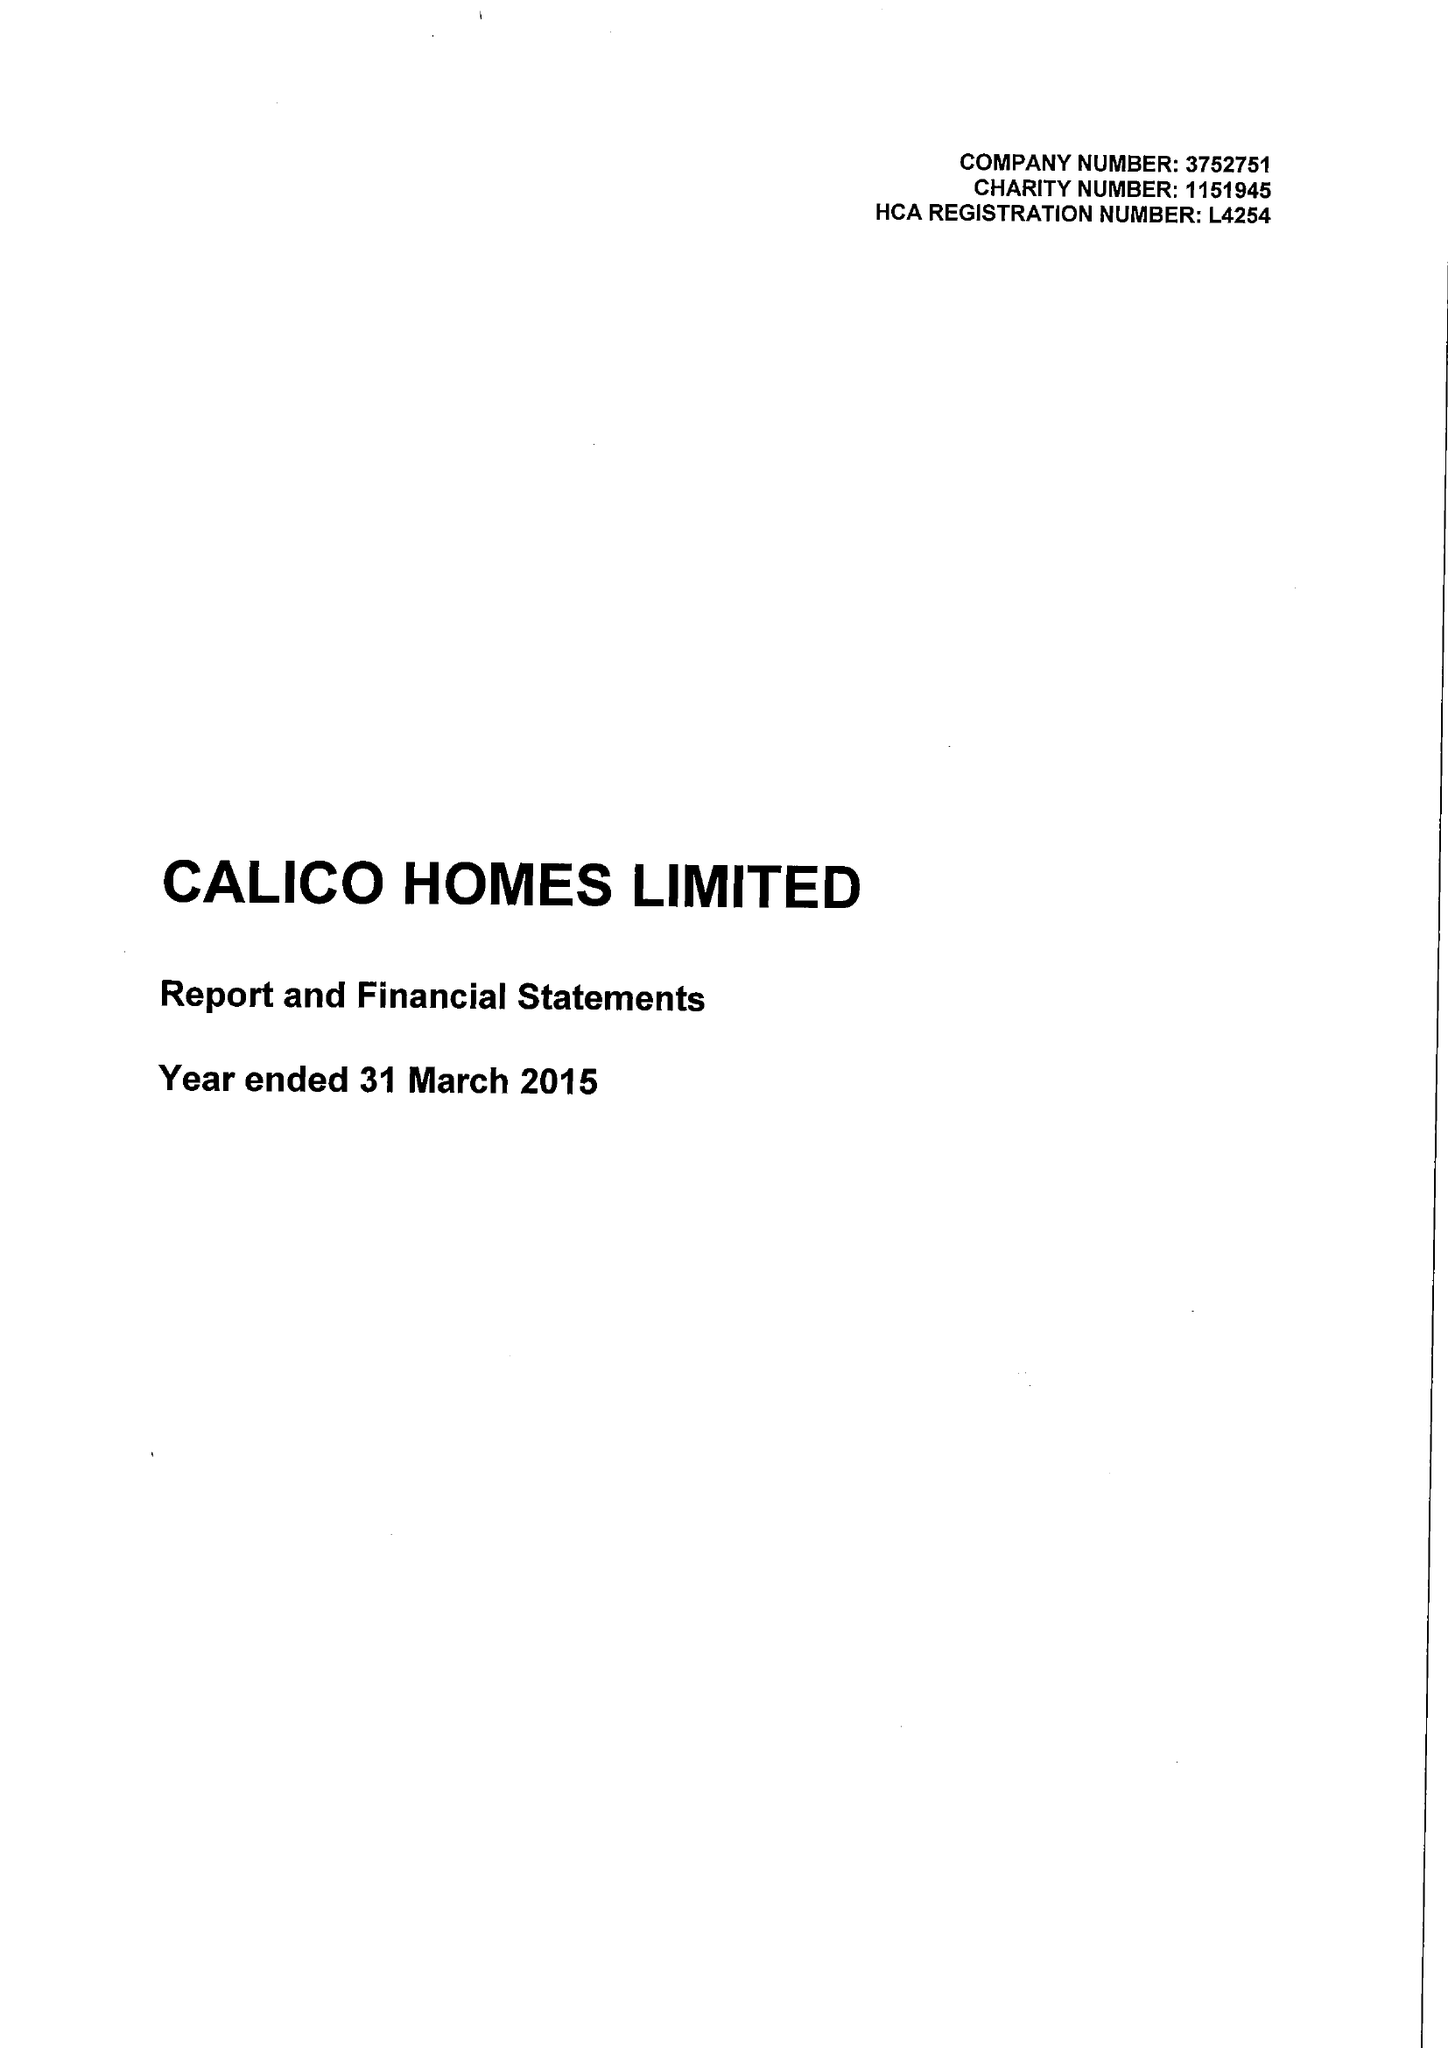What is the value for the charity_number?
Answer the question using a single word or phrase. 1151945 